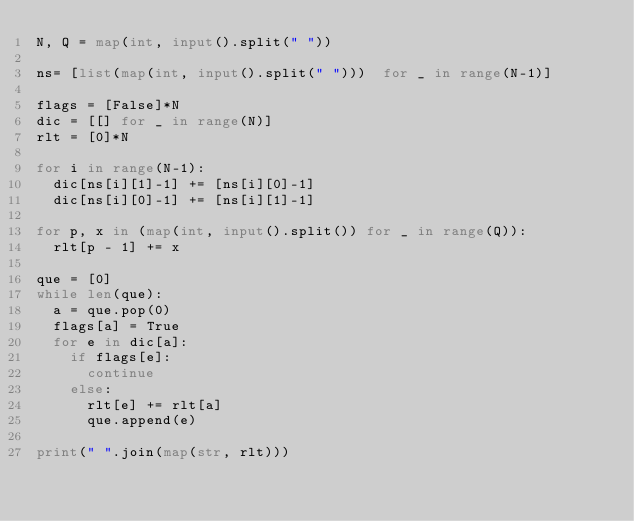<code> <loc_0><loc_0><loc_500><loc_500><_Python_>N, Q = map(int, input().split(" "))
 
ns= [list(map(int, input().split(" ")))  for _ in range(N-1)]
 
flags = [False]*N
dic = [[] for _ in range(N)]
rlt = [0]*N
 
for i in range(N-1):
  dic[ns[i][1]-1] += [ns[i][0]-1]
  dic[ns[i][0]-1] += [ns[i][1]-1]
  
for p, x in (map(int, input().split()) for _ in range(Q)):
  rlt[p - 1] += x

que = [0]
while len(que):
  a = que.pop(0)
  flags[a] = True
  for e in dic[a]:
    if flags[e]:
      continue
    else:
      rlt[e] += rlt[a]
      que.append(e)
    
print(" ".join(map(str, rlt)))</code> 